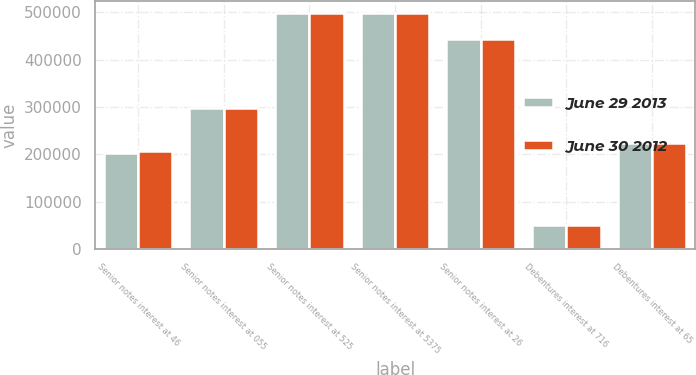<chart> <loc_0><loc_0><loc_500><loc_500><stacked_bar_chart><ecel><fcel>Senior notes interest at 46<fcel>Senior notes interest at 055<fcel>Senior notes interest at 525<fcel>Senior notes interest at 5375<fcel>Senior notes interest at 26<fcel>Debentures interest at 716<fcel>Debentures interest at 65<nl><fcel>June 29 2013<fcel>202190<fcel>298669<fcel>498414<fcel>499669<fcel>444844<fcel>50000<fcel>224641<nl><fcel>June 30 2012<fcel>206673<fcel>297983<fcel>498069<fcel>499654<fcel>444271<fcel>50000<fcel>224617<nl></chart> 